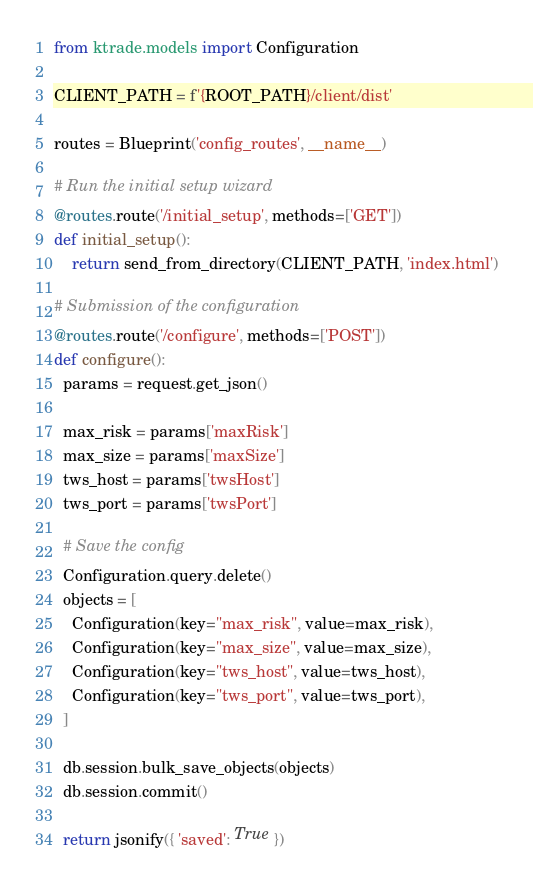<code> <loc_0><loc_0><loc_500><loc_500><_Python_>from ktrade.models import Configuration

CLIENT_PATH = f'{ROOT_PATH}/client/dist'

routes = Blueprint('config_routes', __name__)

# Run the initial setup wizard
@routes.route('/initial_setup', methods=['GET'])
def initial_setup():
    return send_from_directory(CLIENT_PATH, 'index.html')

# Submission of the configuration
@routes.route('/configure', methods=['POST'])
def configure():
  params = request.get_json()

  max_risk = params['maxRisk']
  max_size = params['maxSize']
  tws_host = params['twsHost']
  tws_port = params['twsPort']

  # Save the config
  Configuration.query.delete()
  objects = [
    Configuration(key="max_risk", value=max_risk),
    Configuration(key="max_size", value=max_size),
    Configuration(key="tws_host", value=tws_host),
    Configuration(key="tws_port", value=tws_port),
  ]

  db.session.bulk_save_objects(objects)
  db.session.commit()

  return jsonify({ 'saved': True })
</code> 